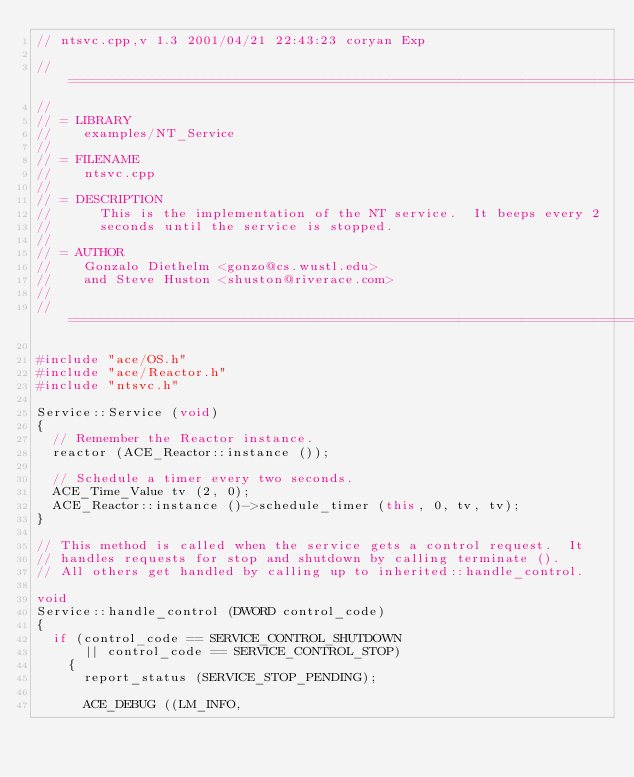Convert code to text. <code><loc_0><loc_0><loc_500><loc_500><_C++_>// ntsvc.cpp,v 1.3 2001/04/21 22:43:23 coryan Exp

// ============================================================================
//
// = LIBRARY
//    examples/NT_Service
//
// = FILENAME
//    ntsvc.cpp
//
// = DESCRIPTION
//      This is the implementation of the NT service.  It beeps every 2
//      seconds until the service is stopped.
//
// = AUTHOR
//    Gonzalo Diethelm <gonzo@cs.wustl.edu>
//    and Steve Huston <shuston@riverace.com>
//
// ============================================================================

#include "ace/OS.h"
#include "ace/Reactor.h"
#include "ntsvc.h"

Service::Service (void)
{
  // Remember the Reactor instance.
  reactor (ACE_Reactor::instance ());

  // Schedule a timer every two seconds.
  ACE_Time_Value tv (2, 0);
  ACE_Reactor::instance ()->schedule_timer (this, 0, tv, tv);
}

// This method is called when the service gets a control request.  It
// handles requests for stop and shutdown by calling terminate ().
// All others get handled by calling up to inherited::handle_control.

void
Service::handle_control (DWORD control_code)
{
  if (control_code == SERVICE_CONTROL_SHUTDOWN
      || control_code == SERVICE_CONTROL_STOP)
    {
      report_status (SERVICE_STOP_PENDING);

      ACE_DEBUG ((LM_INFO,</code> 